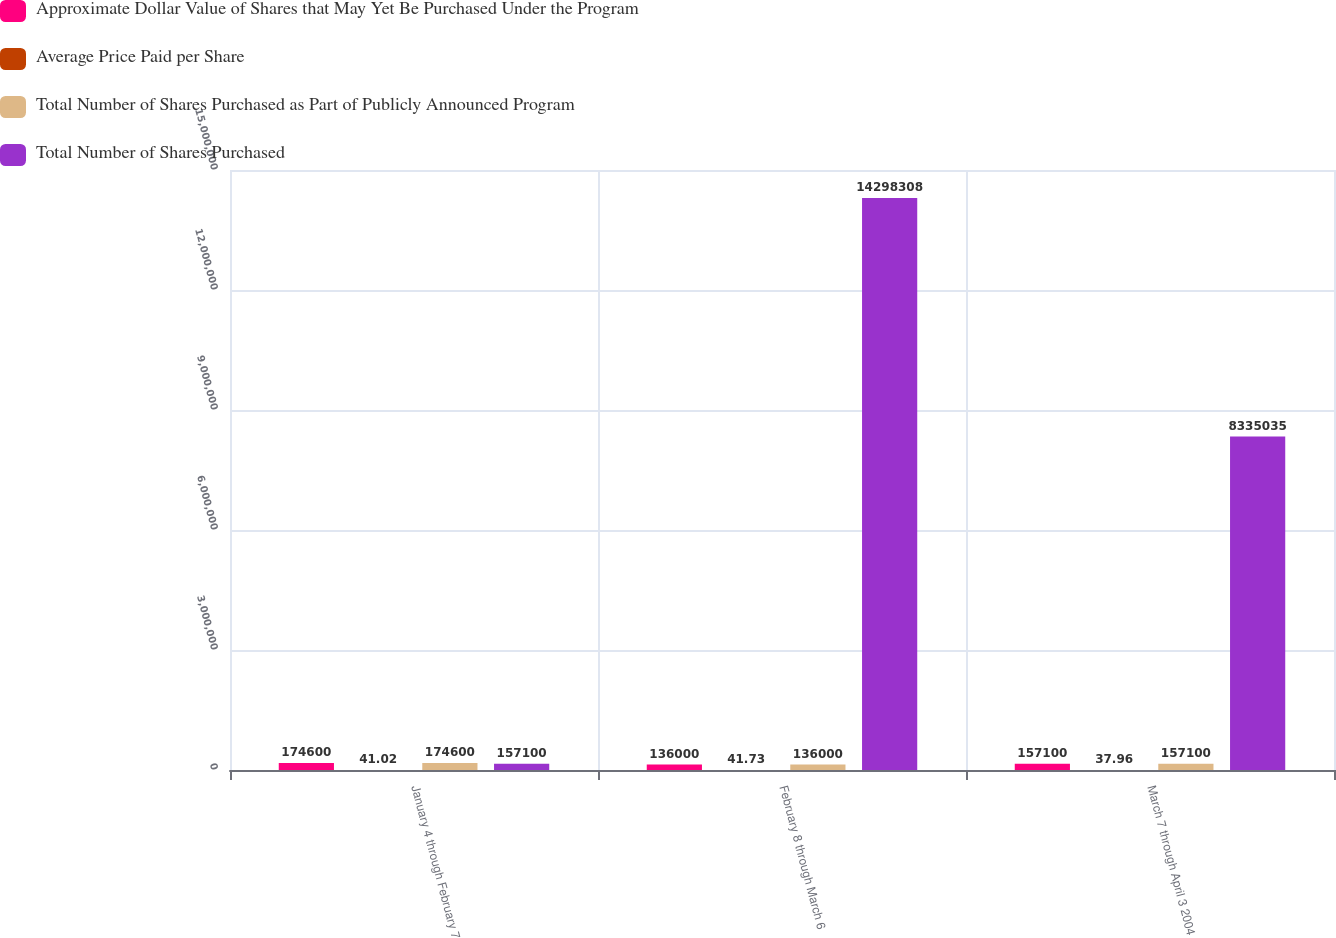Convert chart. <chart><loc_0><loc_0><loc_500><loc_500><stacked_bar_chart><ecel><fcel>January 4 through February 7<fcel>February 8 through March 6<fcel>March 7 through April 3 2004<nl><fcel>Approximate Dollar Value of Shares that May Yet Be Purchased Under the Program<fcel>174600<fcel>136000<fcel>157100<nl><fcel>Average Price Paid per Share<fcel>41.02<fcel>41.73<fcel>37.96<nl><fcel>Total Number of Shares Purchased as Part of Publicly Announced Program<fcel>174600<fcel>136000<fcel>157100<nl><fcel>Total Number of Shares Purchased<fcel>157100<fcel>1.42983e+07<fcel>8.33504e+06<nl></chart> 